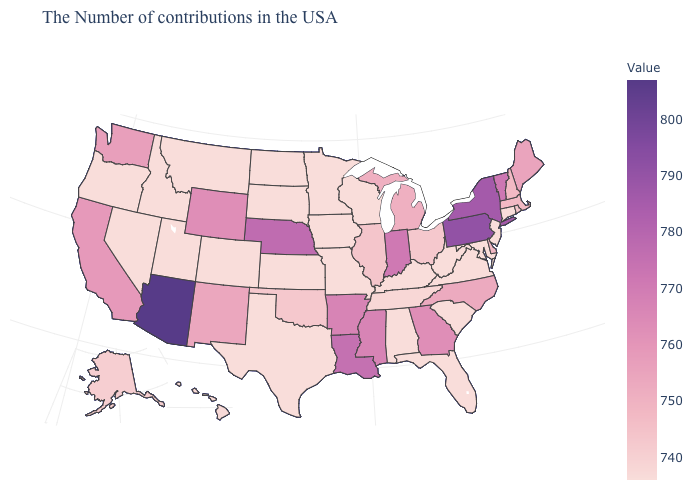Does the map have missing data?
Answer briefly. No. Does Delaware have the highest value in the USA?
Answer briefly. No. Does Alabama have the lowest value in the USA?
Give a very brief answer. Yes. 